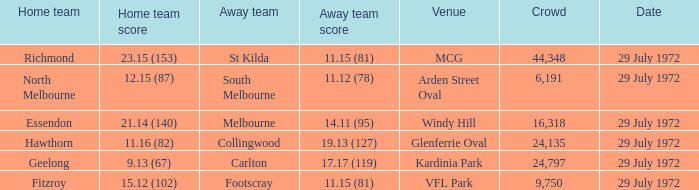When did the visiting team footscray achieve 1 29 July 1972. 